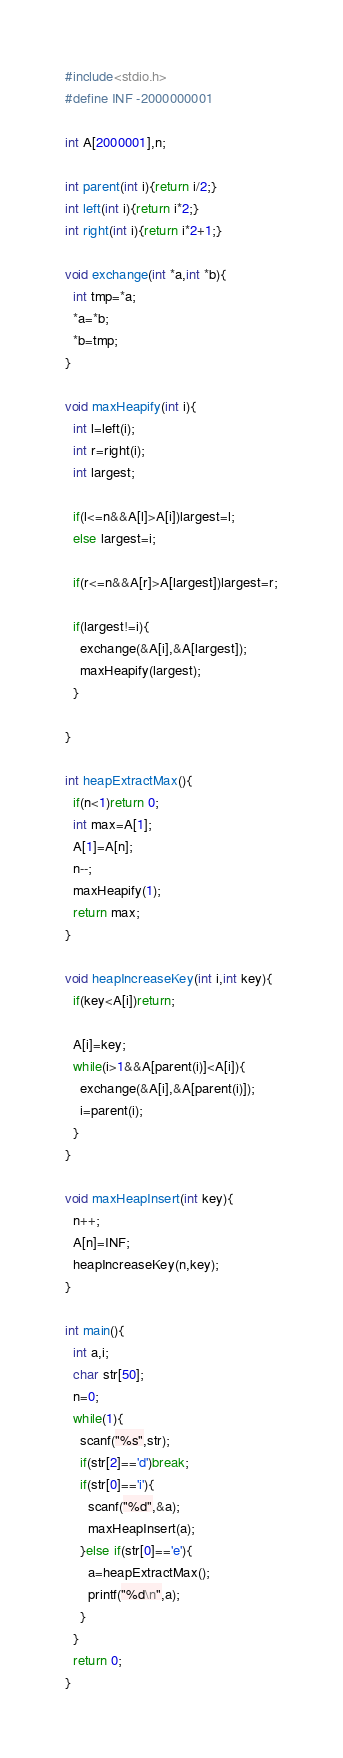<code> <loc_0><loc_0><loc_500><loc_500><_C_>#include<stdio.h>
#define INF -2000000001

int A[2000001],n;

int parent(int i){return i/2;}
int left(int i){return i*2;}
int right(int i){return i*2+1;}

void exchange(int *a,int *b){
  int tmp=*a;
  *a=*b;
  *b=tmp;
}

void maxHeapify(int i){
  int l=left(i);
  int r=right(i);
  int largest;
 
  if(l<=n&&A[l]>A[i])largest=l;
  else largest=i;
 
  if(r<=n&&A[r]>A[largest])largest=r;
 
  if(largest!=i){
    exchange(&A[i],&A[largest]);
    maxHeapify(largest);
  }
 
}

int heapExtractMax(){
  if(n<1)return 0;
  int max=A[1];
  A[1]=A[n];
  n--;
  maxHeapify(1);
  return max;
}

void heapIncreaseKey(int i,int key){
  if(key<A[i])return;

  A[i]=key;
  while(i>1&&A[parent(i)]<A[i]){
    exchange(&A[i],&A[parent(i)]);
    i=parent(i);
  }
}

void maxHeapInsert(int key){
  n++;
  A[n]=INF;
  heapIncreaseKey(n,key);
}

int main(){
  int a,i;
  char str[50];
  n=0;
  while(1){
    scanf("%s",str);
    if(str[2]=='d')break;
    if(str[0]=='i'){
      scanf("%d",&a);
      maxHeapInsert(a);
    }else if(str[0]=='e'){
      a=heapExtractMax();
      printf("%d\n",a);
    }
  }
  return 0;
}</code> 